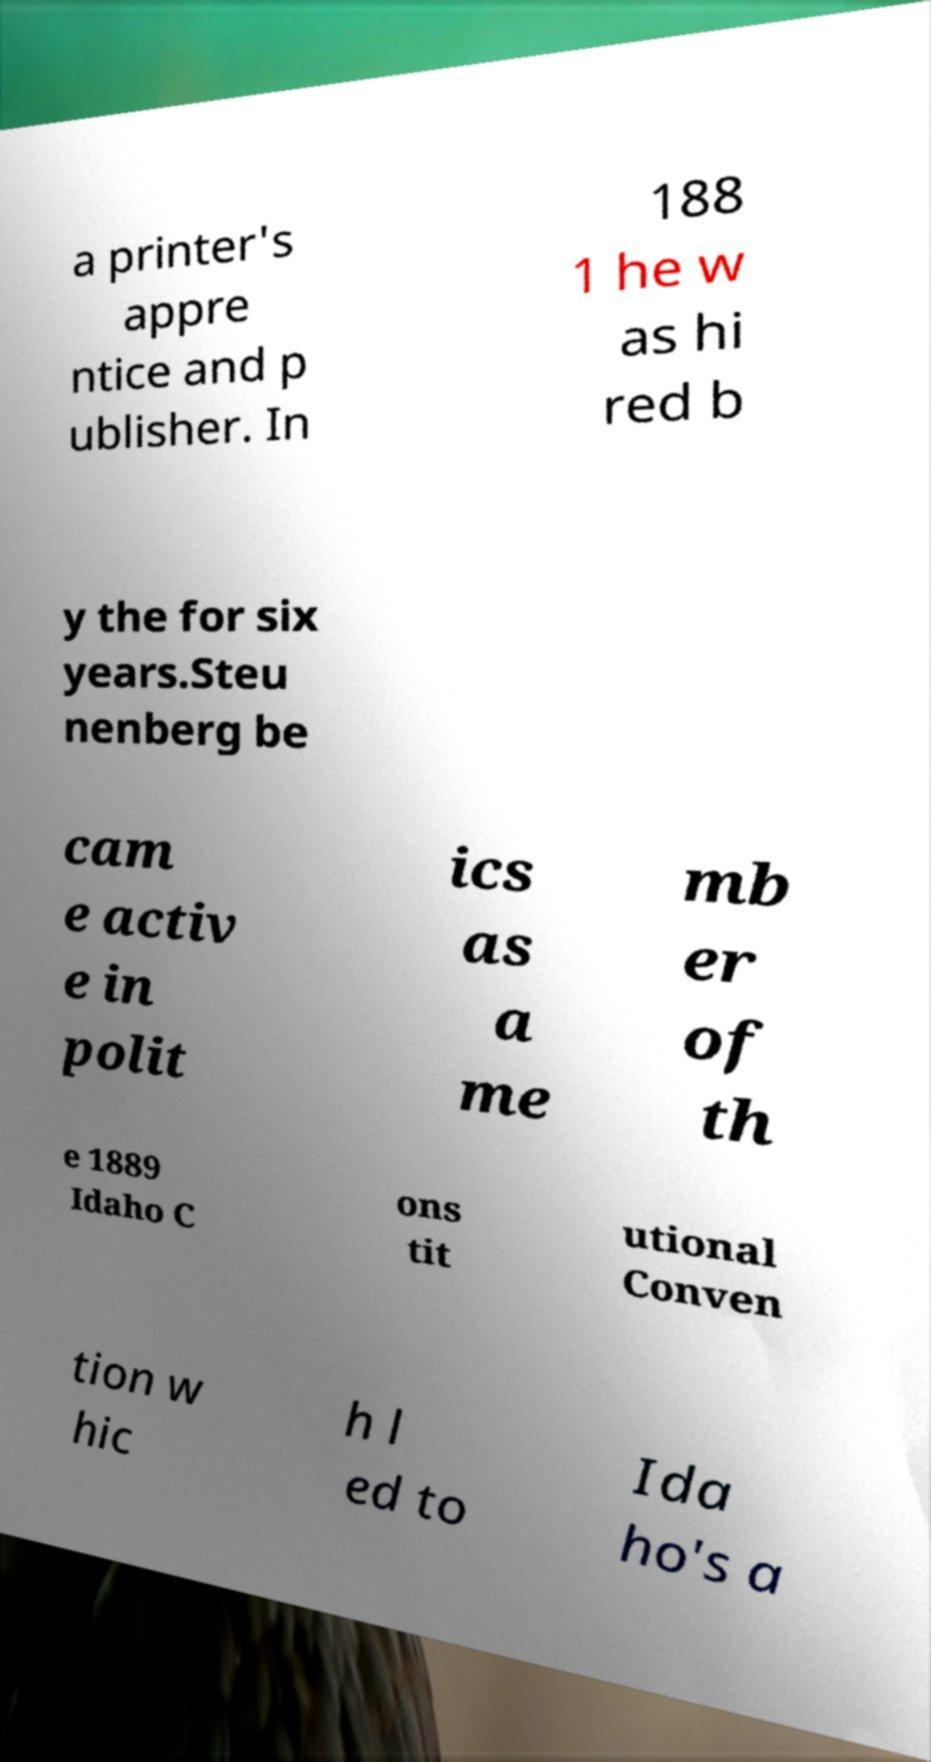What messages or text are displayed in this image? I need them in a readable, typed format. a printer's appre ntice and p ublisher. In 188 1 he w as hi red b y the for six years.Steu nenberg be cam e activ e in polit ics as a me mb er of th e 1889 Idaho C ons tit utional Conven tion w hic h l ed to Ida ho's a 